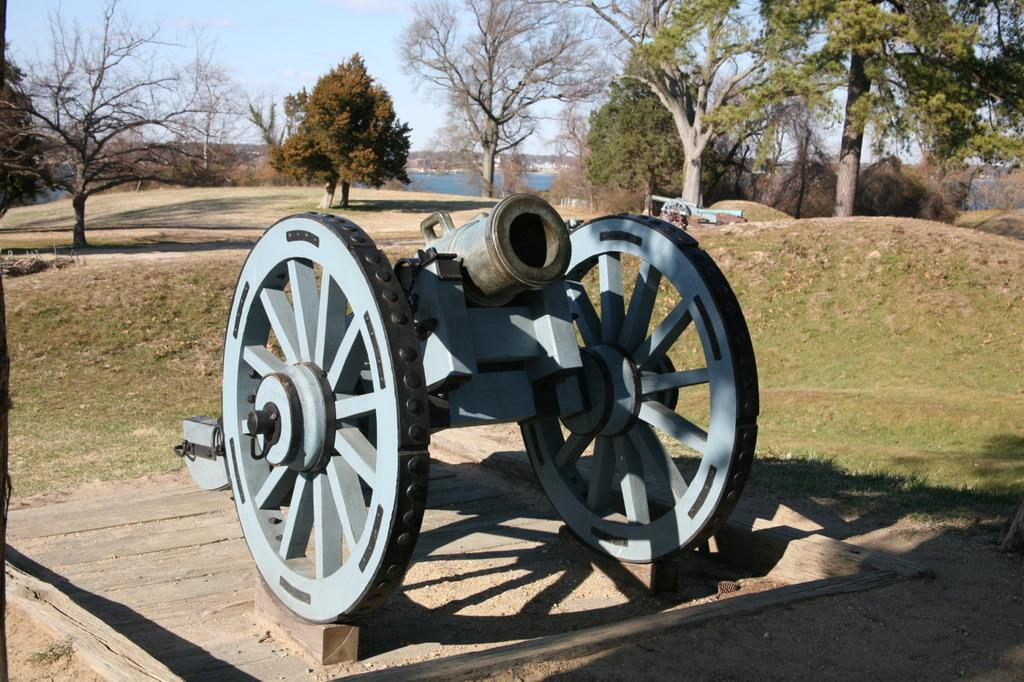What is the main object in the image? There is a cannon in the image. What type of natural environment is depicted in the image? There are trees and grass on the ground in the image. What can be seen in the water in the image? The facts do not specify what can be seen in the water. What is visible in the sky in the image? There is a cloud in the sky in the image. What sound does the beetle make while crawling on the dad's shoulder in the image? There is no beetle or dad present in the image, so it is not possible to answer that question. 